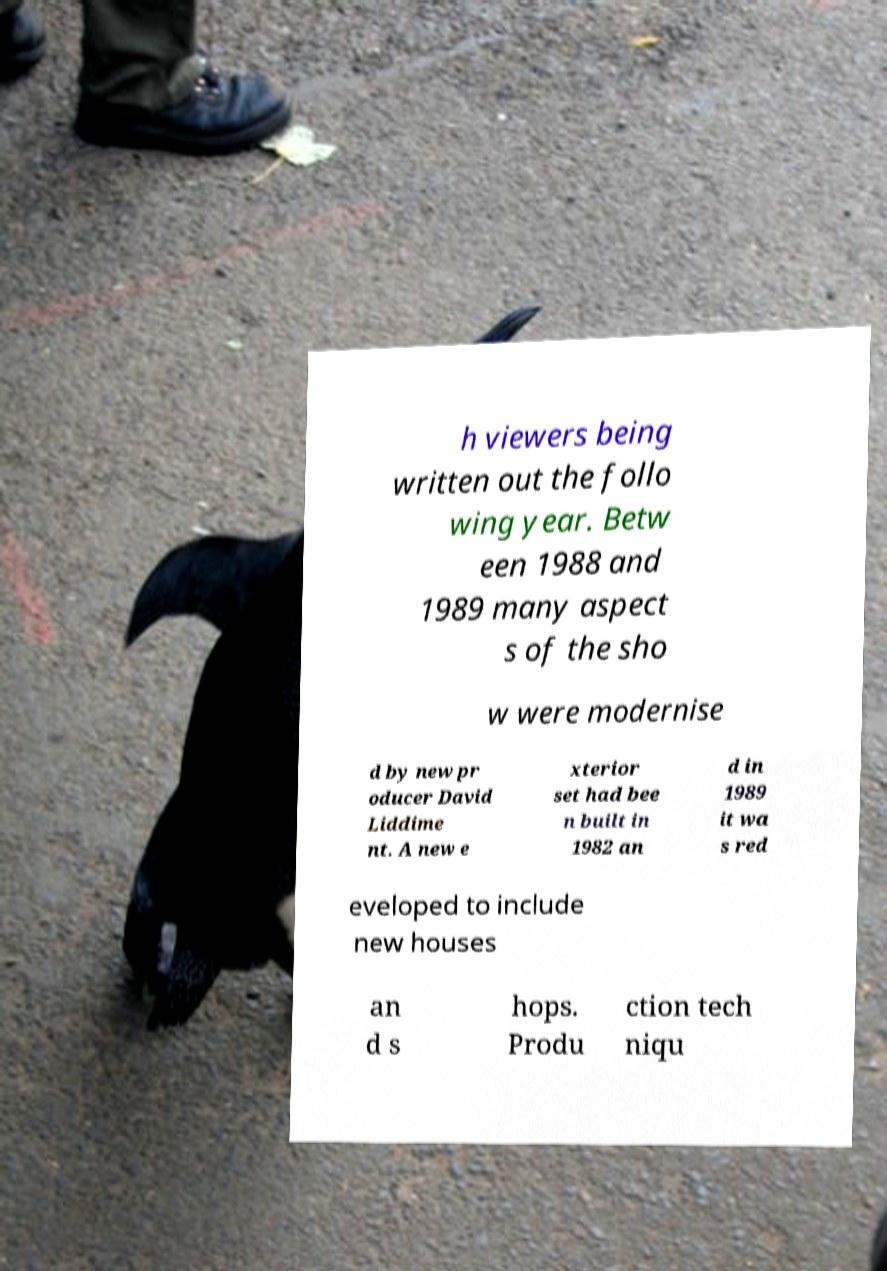I need the written content from this picture converted into text. Can you do that? h viewers being written out the follo wing year. Betw een 1988 and 1989 many aspect s of the sho w were modernise d by new pr oducer David Liddime nt. A new e xterior set had bee n built in 1982 an d in 1989 it wa s red eveloped to include new houses an d s hops. Produ ction tech niqu 